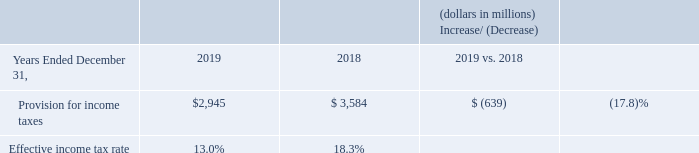Provision for Income Taxes
The effective income tax rate is calculated by dividing the provision for income taxes by income before income taxes. The effective income tax rate for 2019 was 13.0% compared to 18.3% for 2018.
The decrease in the effective income tax rate and the provision for income taxes was primarily due to the recognition of approximately $2.2 billion of a non-recurring tax benefit in connection with the disposition of preferred stock, representing a minority interest in a foreign affiliate in 2019 compared to the non-recurring deferred tax benefit of approximately $2.1 billion as a result of an internal reorganization of legal entities within the historical Wireless business, which was offset by a goodwill charge that is not deductible for tax purposes in 2018.
A reconciliation of the statutory federal income tax rate to the effective income tax rate for each period is included in Note 12 to the consolidated financial statements.
What was the effective income tax rate for the period 2019? 13.0%. What was the effective income tax rate for the period 2018? 18.3%. What led to non-recurring deferred tax benefit of approximately $2.1 billion? An internal reorganization of legal entities within the historical wireless business. What is the change in Provision for income taxes from 2018 to 2019?
Answer scale should be: million. 2,945-3,584
Answer: -639. What is the change in Effective income tax rate from 2018 to 2019?
Answer scale should be: percent. 13.0-18.3
Answer: -5.3. What is the average Effective income tax rate for 2018 and 2019?
Answer scale should be: percent. (13.0+18.3) / 2
Answer: 15.65. 